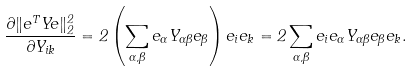Convert formula to latex. <formula><loc_0><loc_0><loc_500><loc_500>\frac { \partial \| e ^ { T } Y e \| _ { 2 } ^ { 2 } } { \partial Y _ { i k } } = 2 \left ( \sum _ { \alpha , \beta } e _ { \alpha } Y _ { \alpha \beta } e _ { \beta } \right ) e _ { i } e _ { k } = 2 \sum _ { \alpha , \beta } e _ { i } e _ { \alpha } Y _ { \alpha \beta } e _ { \beta } e _ { k } .</formula> 